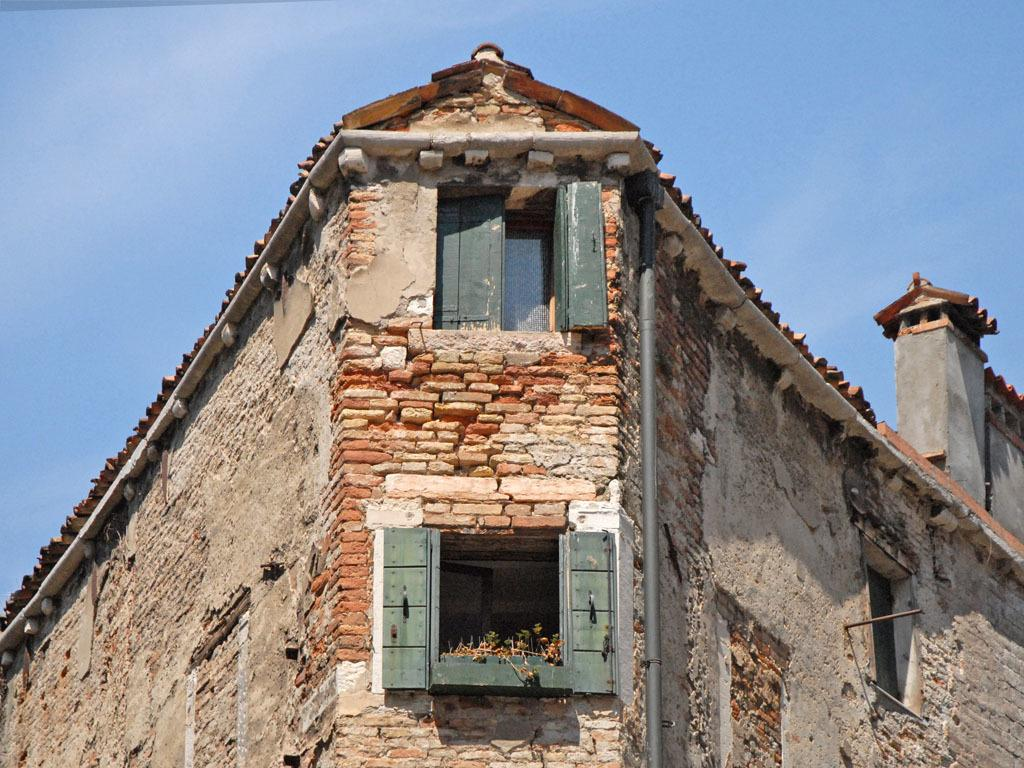What is the main subject of the picture? The main subject of the picture is a building. What specific features can be seen on the building? The building has windows. What can be seen in the background of the picture? The sky is visible in the background of the picture. What type of party is happening in the building in the image? There is no indication of a party happening in the building in the image. Can you see any badges or insignia on the building in the image? There is no mention of badges or insignia on the building in the image. 